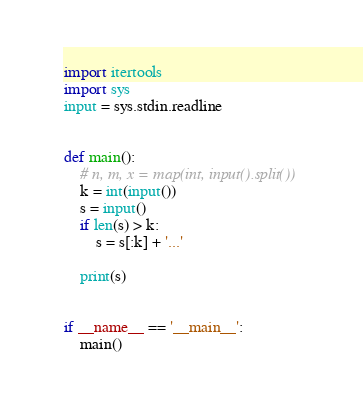Convert code to text. <code><loc_0><loc_0><loc_500><loc_500><_Python_>import itertools
import sys
input = sys.stdin.readline


def main():
    # n, m, x = map(int, input().split())
    k = int(input())
    s = input()
    if len(s) > k:
        s = s[:k] + '...'

    print(s)


if __name__ == '__main__':
    main()</code> 